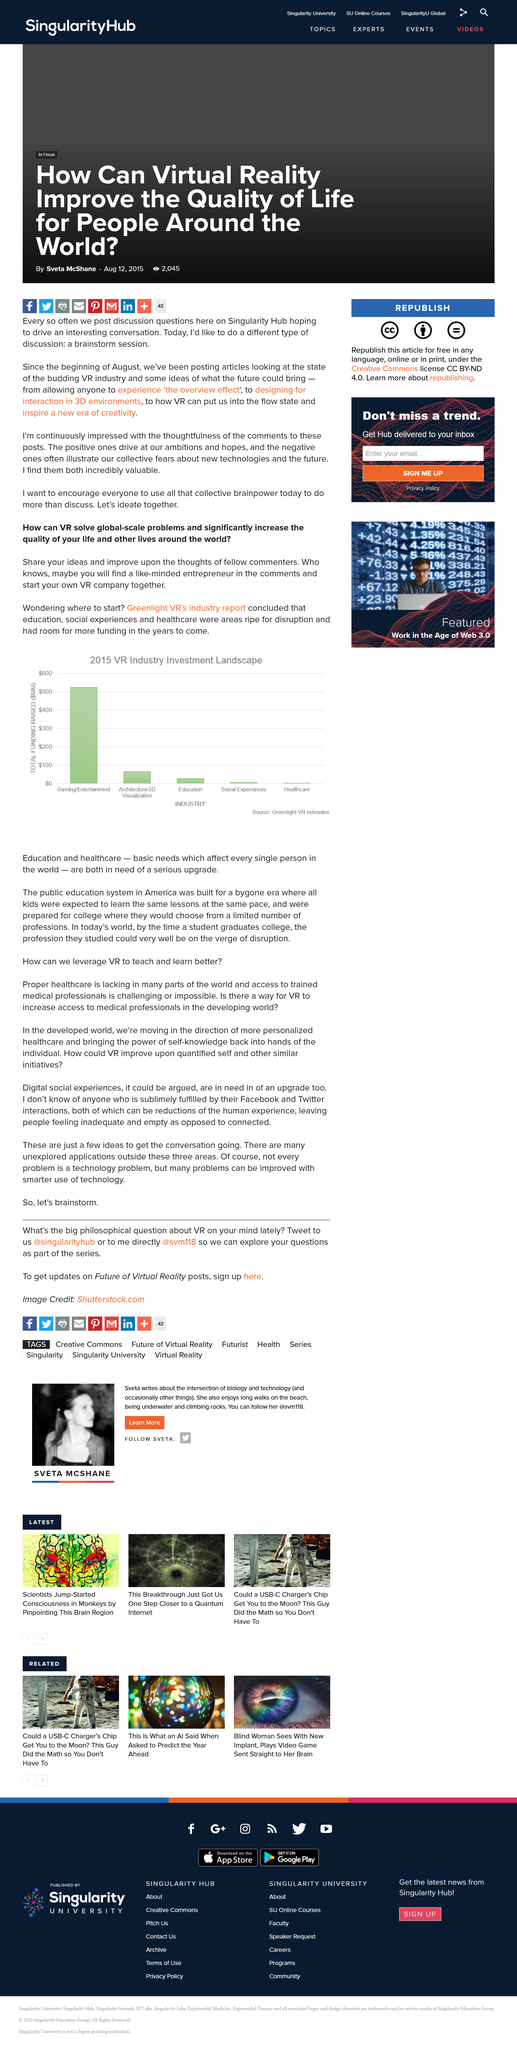Indicate a few pertinent items in this graphic. Greenlight VR's industry report concluded that education, social experiences, and healthcare are ripe for disruption based on released data. A majority of investment in the VR industry is being directed towards the gaming and entertainment sector. The public education system in America is outdated and in need of significant improvement, as it was designed for a bygone era where all students were expected to learn the same lessons at the same pace. 